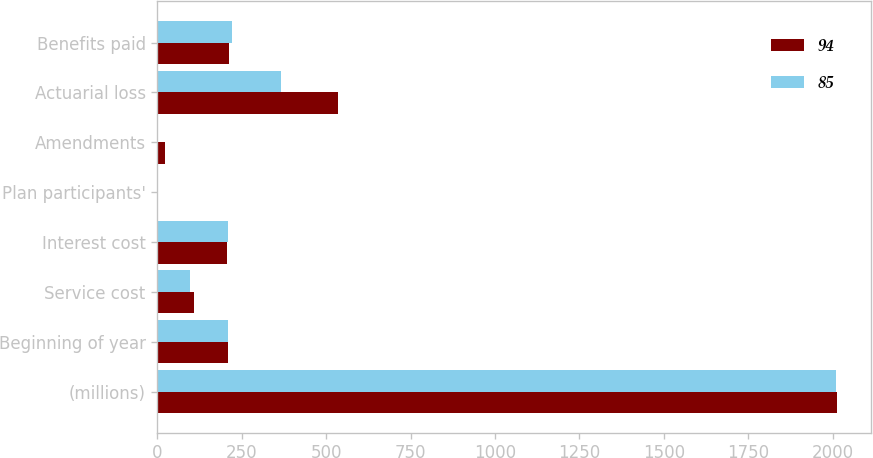Convert chart. <chart><loc_0><loc_0><loc_500><loc_500><stacked_bar_chart><ecel><fcel>(millions)<fcel>Beginning of year<fcel>Service cost<fcel>Interest cost<fcel>Plan participants'<fcel>Amendments<fcel>Actuarial loss<fcel>Benefits paid<nl><fcel>94<fcel>2012<fcel>208<fcel>110<fcel>207<fcel>2<fcel>23<fcel>535<fcel>213<nl><fcel>85<fcel>2011<fcel>208<fcel>96<fcel>209<fcel>2<fcel>3<fcel>365<fcel>220<nl></chart> 